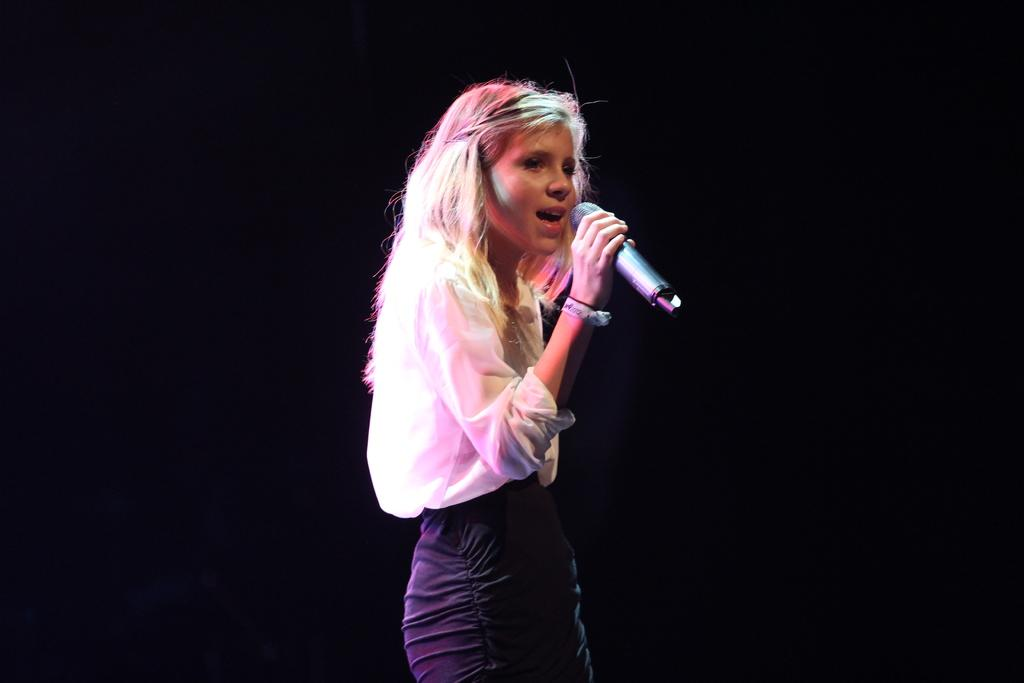Who is the main subject in the image? There is a lady in the image. What is the lady doing in the image? The lady is singing. What object is the lady holding in the image? The lady is holding a mic in one of her hands. What is the color of the background in the image? The background of the image is black in color. What arithmetic problem is the lady solving in the image? There is no arithmetic problem present in the image; the lady is singing and holding a mic. What attraction is the lady visiting in the image? There is no attraction mentioned or visible in the image; the lady is singing and holding a mic in a setting with a black background. 